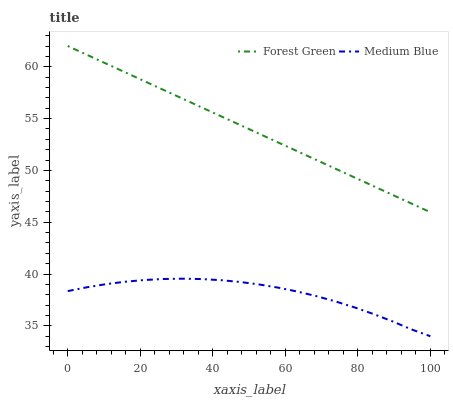Does Medium Blue have the minimum area under the curve?
Answer yes or no. Yes. Does Forest Green have the maximum area under the curve?
Answer yes or no. Yes. Does Medium Blue have the maximum area under the curve?
Answer yes or no. No. Is Forest Green the smoothest?
Answer yes or no. Yes. Is Medium Blue the roughest?
Answer yes or no. Yes. Is Medium Blue the smoothest?
Answer yes or no. No. Does Medium Blue have the lowest value?
Answer yes or no. Yes. Does Forest Green have the highest value?
Answer yes or no. Yes. Does Medium Blue have the highest value?
Answer yes or no. No. Is Medium Blue less than Forest Green?
Answer yes or no. Yes. Is Forest Green greater than Medium Blue?
Answer yes or no. Yes. Does Medium Blue intersect Forest Green?
Answer yes or no. No. 